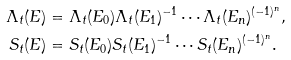<formula> <loc_0><loc_0><loc_500><loc_500>\Lambda _ { t } ( E ) & = \Lambda _ { t } ( E _ { 0 } ) \Lambda _ { t } ( E _ { 1 } ) ^ { - 1 } \cdots \Lambda _ { t } ( E _ { n } ) ^ { ( - 1 ) ^ { n } } , \\ S _ { t } ( E ) & = S _ { t } ( E _ { 0 } ) S _ { t } ( E _ { 1 } ) ^ { - 1 } \cdots S _ { t } ( E _ { n } ) ^ { ( - 1 ) ^ { n } } .</formula> 